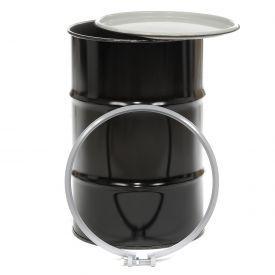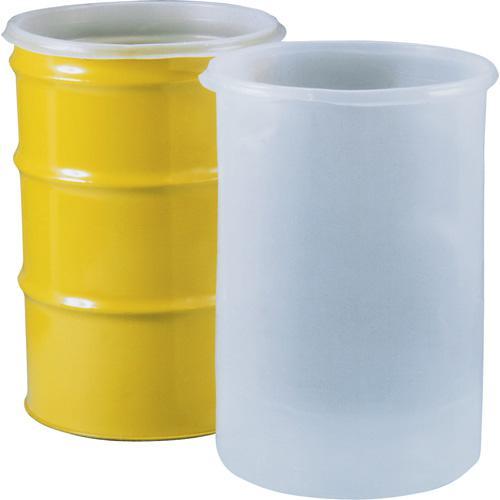The first image is the image on the left, the second image is the image on the right. Assess this claim about the two images: "One image shows a barrel with a yellow end being hoisted by a blue lift that grips either end and is attached to a hook.". Correct or not? Answer yes or no. No. The first image is the image on the left, the second image is the image on the right. For the images displayed, is the sentence "The barrels in the images are hanging horizontally." factually correct? Answer yes or no. No. 